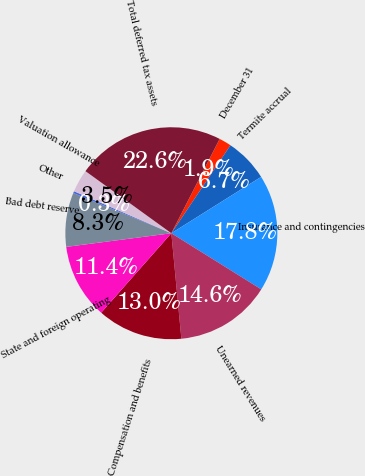<chart> <loc_0><loc_0><loc_500><loc_500><pie_chart><fcel>December 31<fcel>Termite accrual<fcel>Insurance and contingencies<fcel>Unearned revenues<fcel>Compensation and benefits<fcel>State and foreign operating<fcel>Bad debt reserve<fcel>Other<fcel>Valuation allowance<fcel>Total deferred tax assets<nl><fcel>1.88%<fcel>6.66%<fcel>17.8%<fcel>14.61%<fcel>13.02%<fcel>11.43%<fcel>8.25%<fcel>0.29%<fcel>3.48%<fcel>22.57%<nl></chart> 